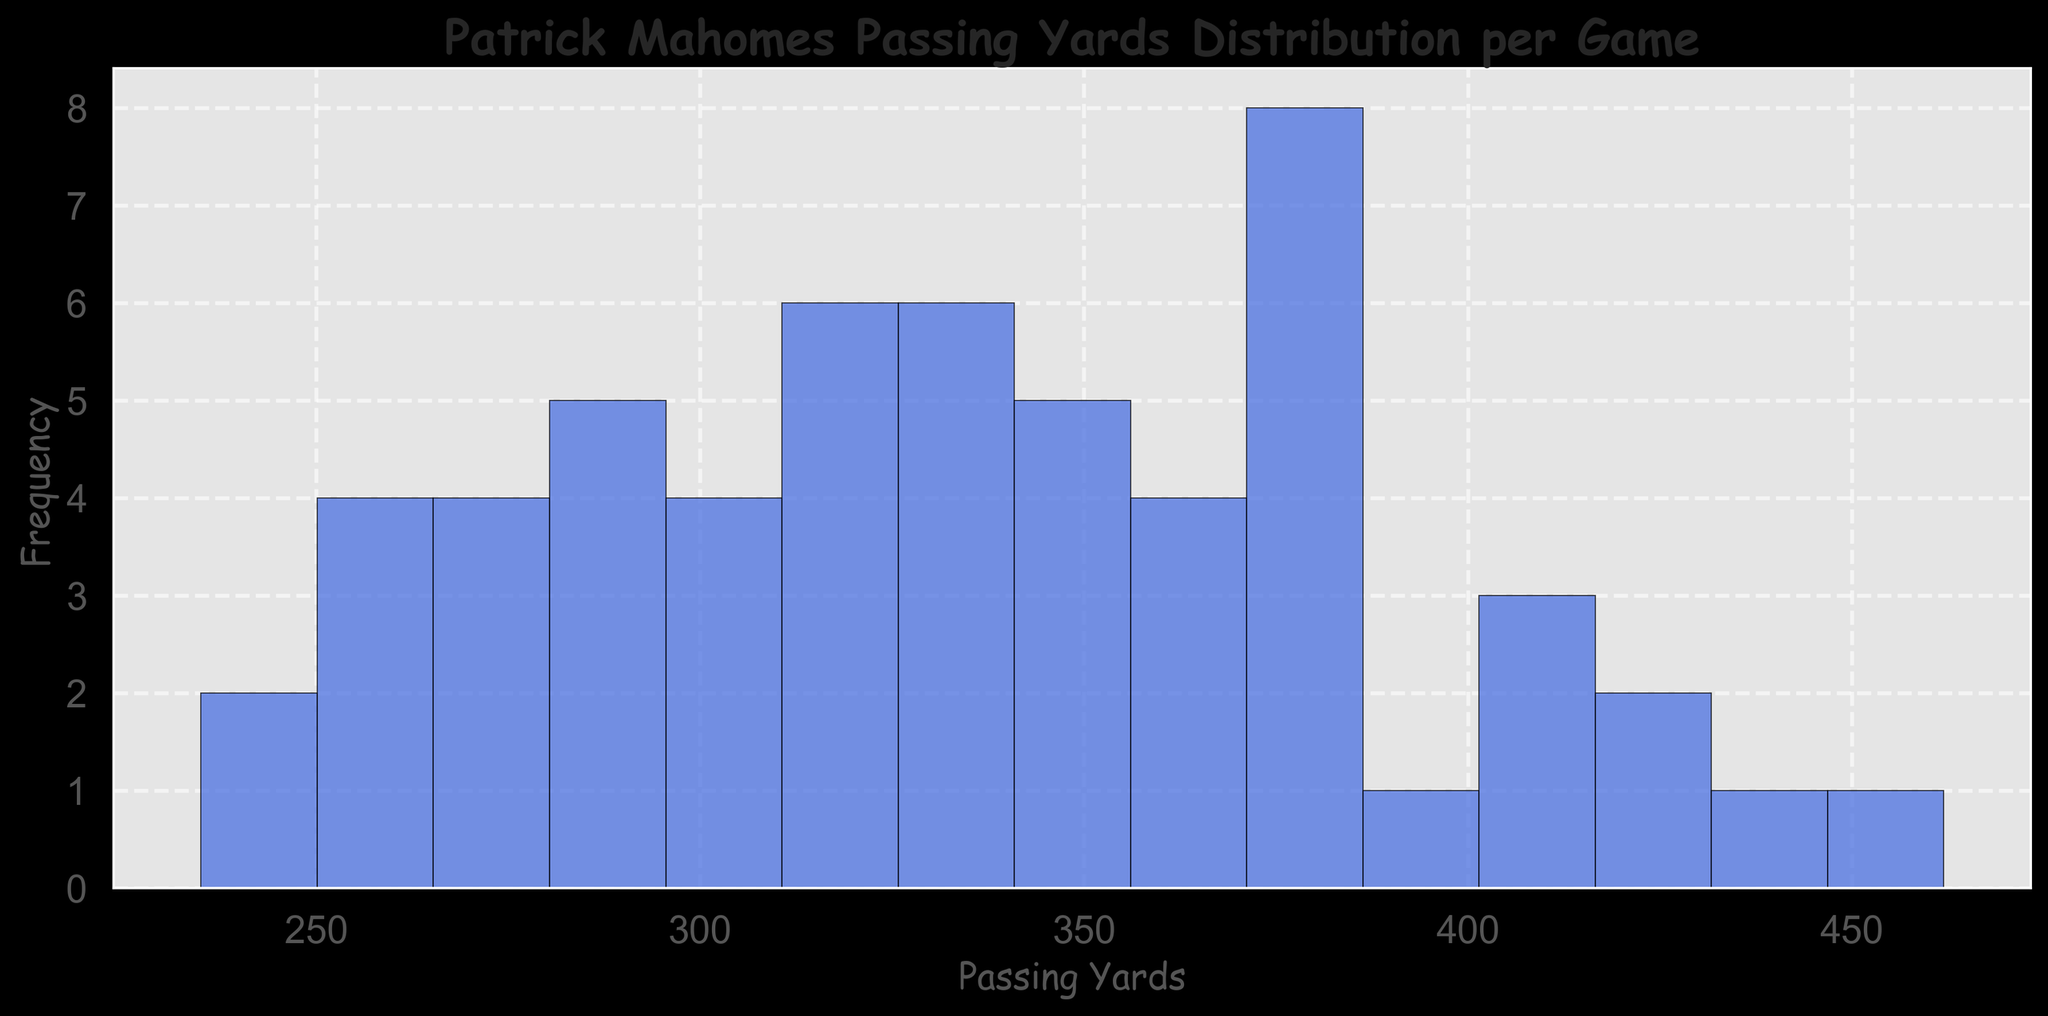What is the most common range of passing yards for Patrick Mahomes based on the histogram? Look at the histogram and identify the bar that is the highest, which represents the most frequent passing yard range.
Answer: 300-350 yards How many games did Patrick Mahomes have with passing yards more than 400? Count the bars to the right of the “400” mark on the x-axis to determine how many games fall into this category.
Answer: 4 games What is the total number of games where Mahomes threw between 250 and 300 passing yards? Add the frequencies of bars within the 250-300 passing yard range.
Answer: 12 games Is there any passing yard range where Patrick Mahomes has no games? Look at the histogram and check if there are any gaps with no bars between the passing yard ranges.
Answer: Yes, from 462-500 yards What is the average range of passing yards per game for Patrick Mahomes? Identify the range where the bars tend to cluster more around the middle point of the histogram.
Answer: 300-350 yards Compare the frequency of games where Mahomes had passing yards between 350-400 and 400-450. Which is more? Compare the height of the bars in the 350-400 range to those in the 400-450 range.
Answer: 350-400 is more Which season does Patrick Mahomes appear to have the highest passing yards based on the distribution in the histogram? Identify the seasons, if any are color-coded, or refer to the labels to determine which season has more games in the higher passing yard ranges.
Answer: 2020 season What is the maximum passing yard shown in the histogram for any single game? Look at the uppermost range value on the x-axis of the histogram.
Answer: 462 yards How does the frequency of games with 200-250 passing yards compare to those with 300-350 passing yards? Compare the heights of bars for the 200-250 range with those in the 300-350 range.
Answer: 200-250 is lower How frequently does Mahomes throw between 350-400 yards in a game based on the histogram? Look at the height of the bar representing the 350-400 range.
Answer: Around 7 games 